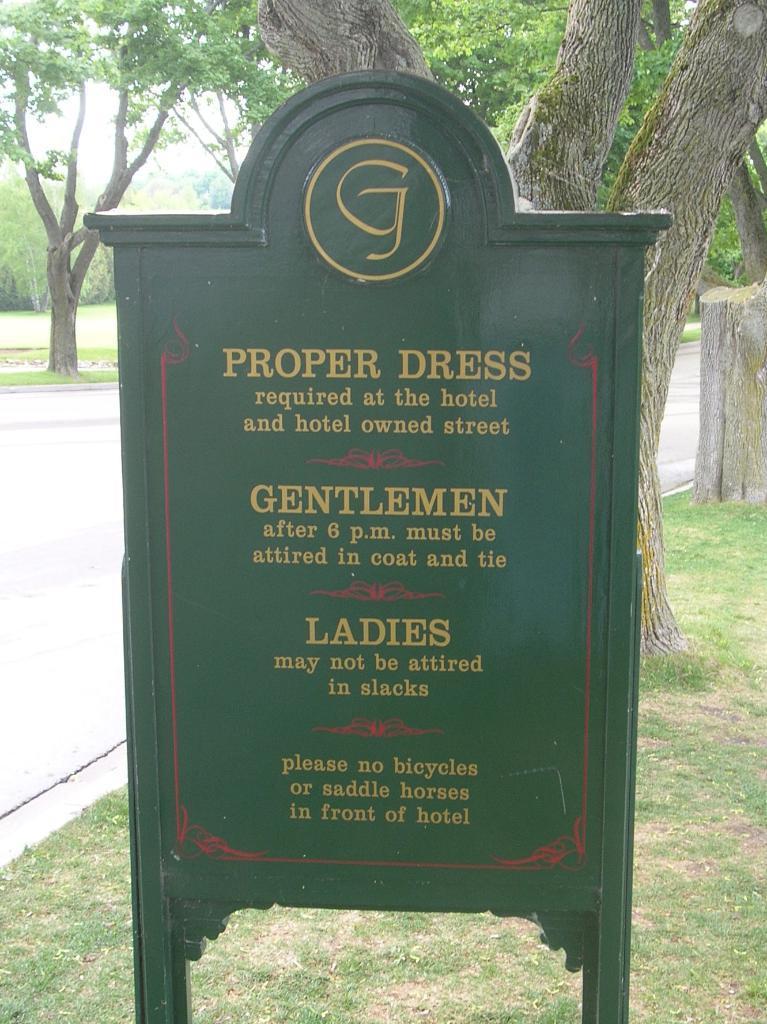In one or two sentences, can you explain what this image depicts? In this image there is a name board, on which there is a text, behind it there are some trees, a road visible on the left side. 